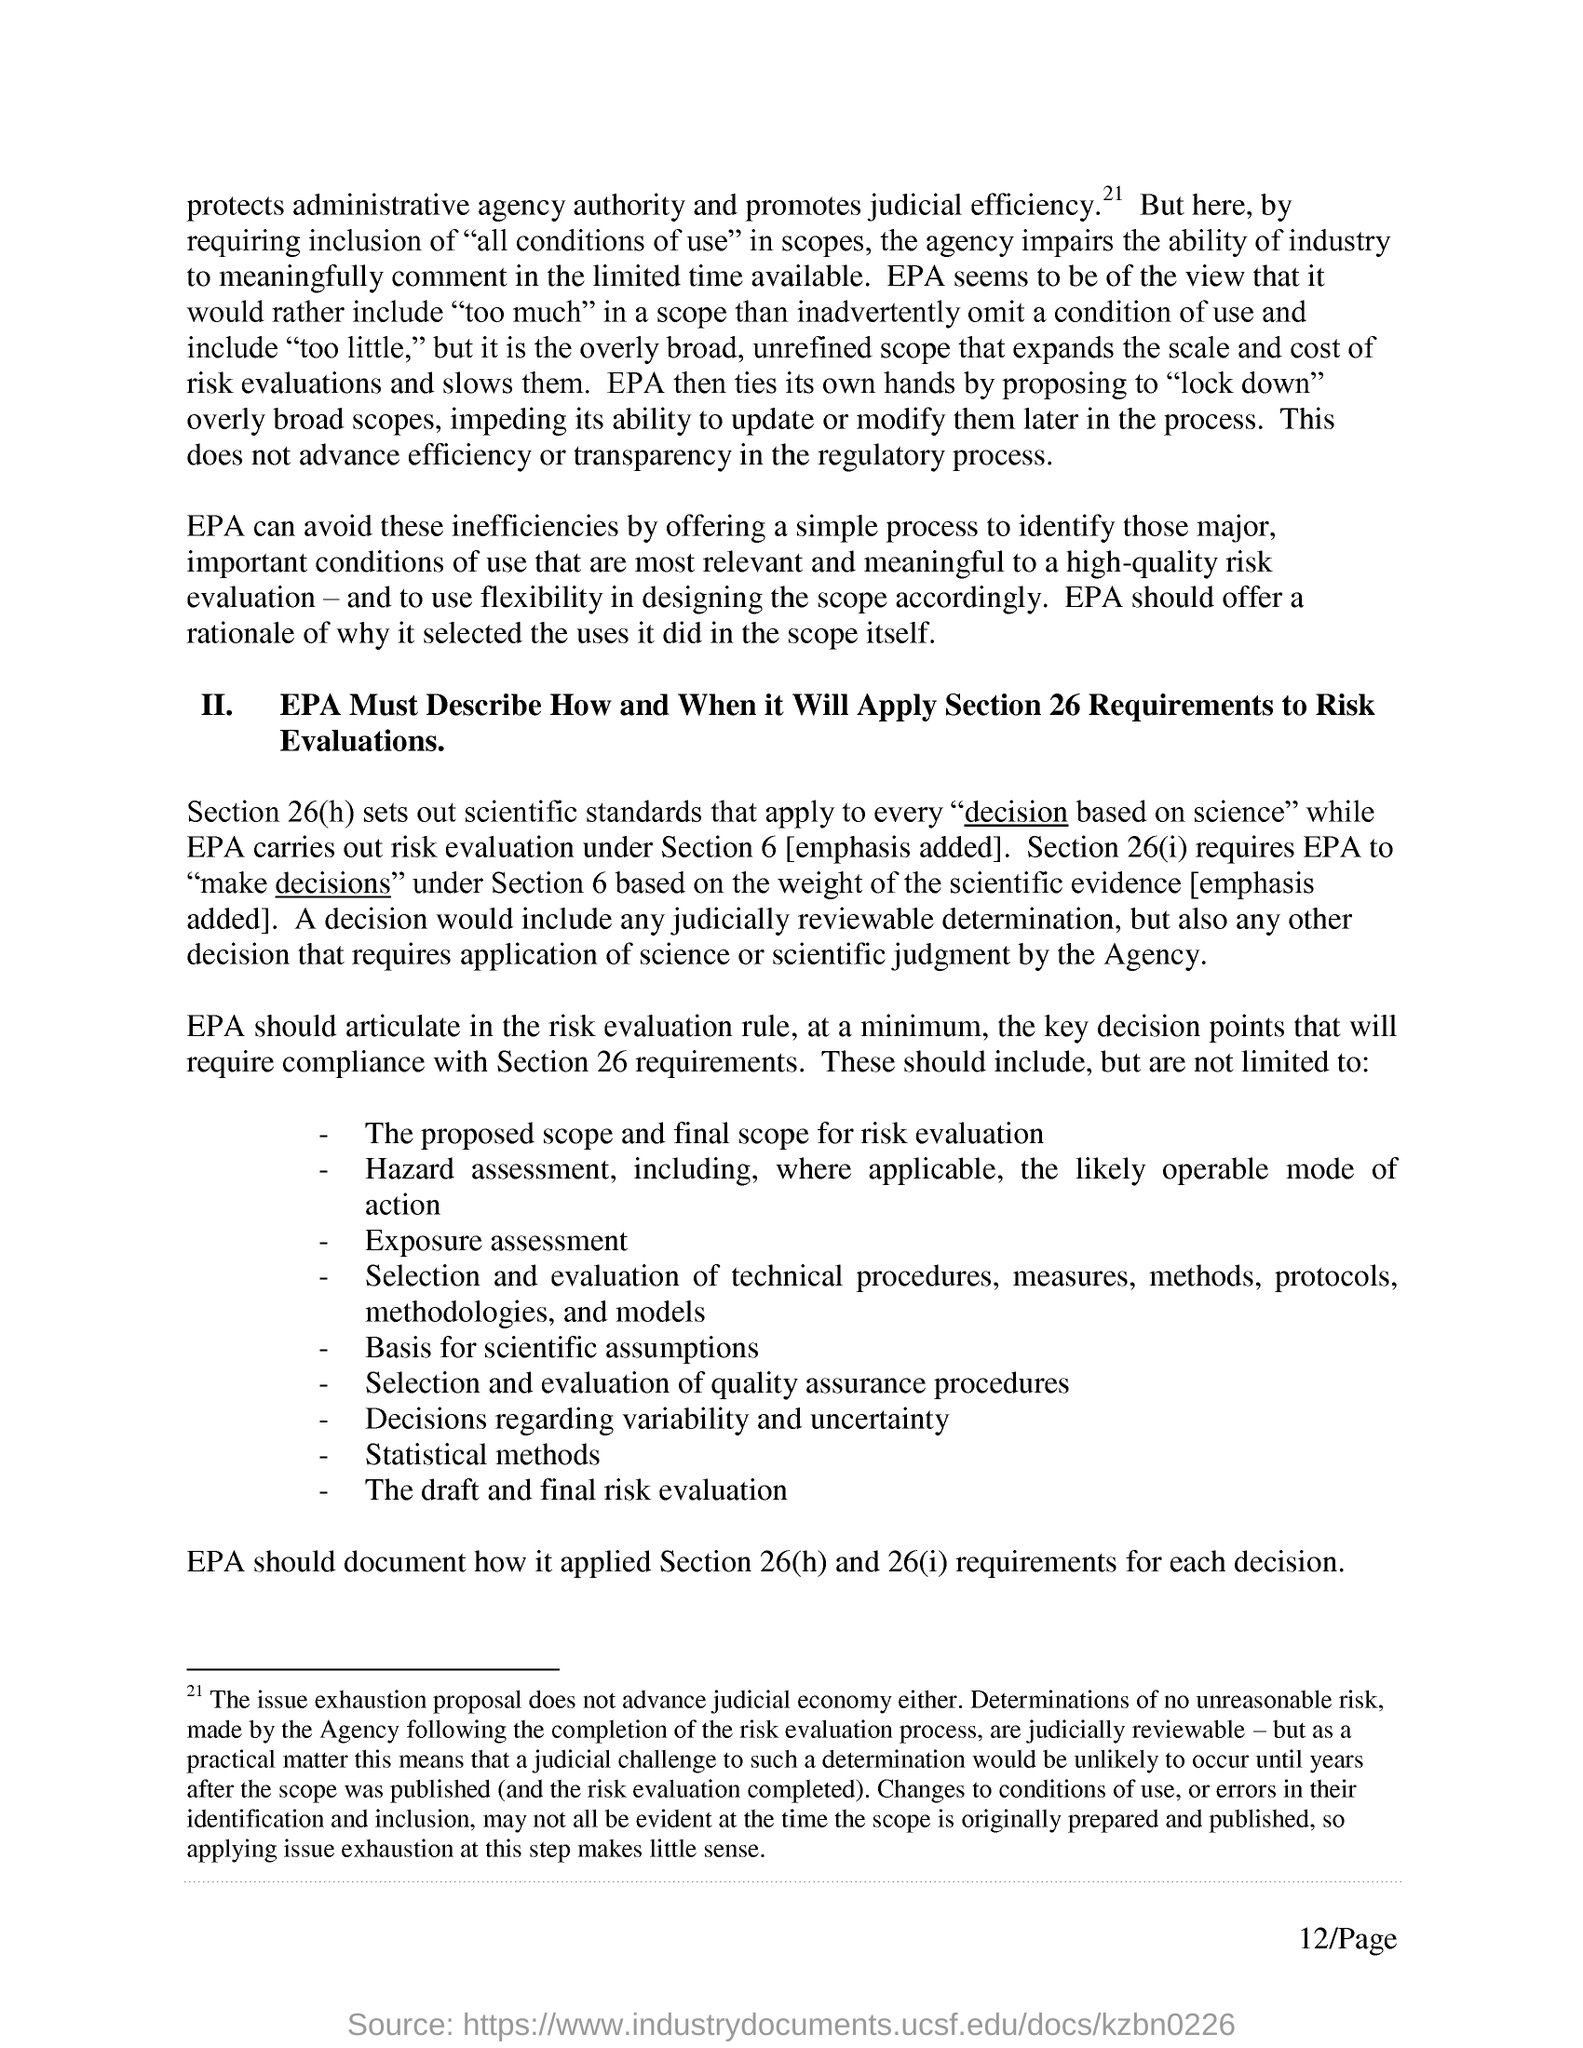What does Section 26(h) set out?
Your answer should be compact. Scientific standards that apply to every "decision based on science". Under which section, EPA carries out risk evaluation?
Provide a succinct answer. Section 6. 